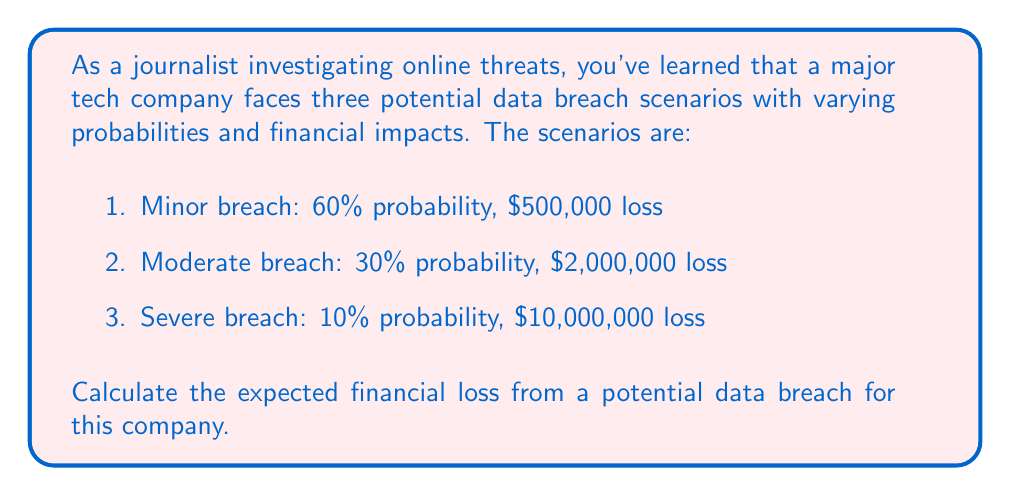Show me your answer to this math problem. To calculate the expected financial loss, we need to use the concept of expected value. The expected value is the sum of each possible outcome multiplied by its probability.

Let's break it down step-by-step:

1. For the minor breach:
   Probability = 60% = 0.60
   Loss = $500,000
   Expected loss = $500,000 × 0.60 = $300,000

2. For the moderate breach:
   Probability = 30% = 0.30
   Loss = $2,000,000
   Expected loss = $2,000,000 × 0.30 = $600,000

3. For the severe breach:
   Probability = 10% = 0.10
   Loss = $10,000,000
   Expected loss = $10,000,000 × 0.10 = $1,000,000

Now, we sum up all the expected losses:

$$ \text{Total Expected Loss} = $300,000 + $600,000 + $1,000,000 = $1,900,000 $$

Therefore, the expected financial loss from a potential data breach for this company is $1,900,000.
Answer: $1,900,000 